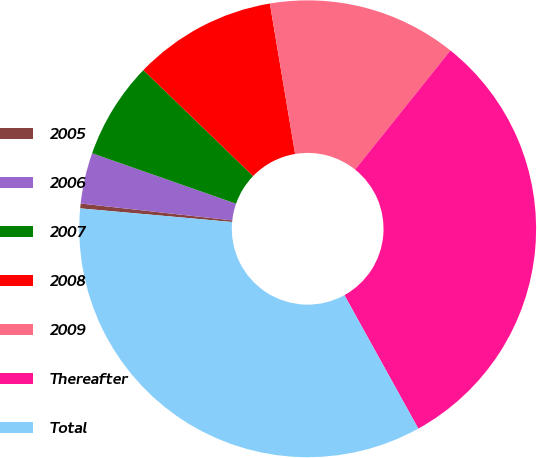Convert chart. <chart><loc_0><loc_0><loc_500><loc_500><pie_chart><fcel>2005<fcel>2006<fcel>2007<fcel>2008<fcel>2009<fcel>Thereafter<fcel>Total<nl><fcel>0.34%<fcel>3.6%<fcel>6.86%<fcel>10.13%<fcel>13.39%<fcel>31.21%<fcel>34.47%<nl></chart> 